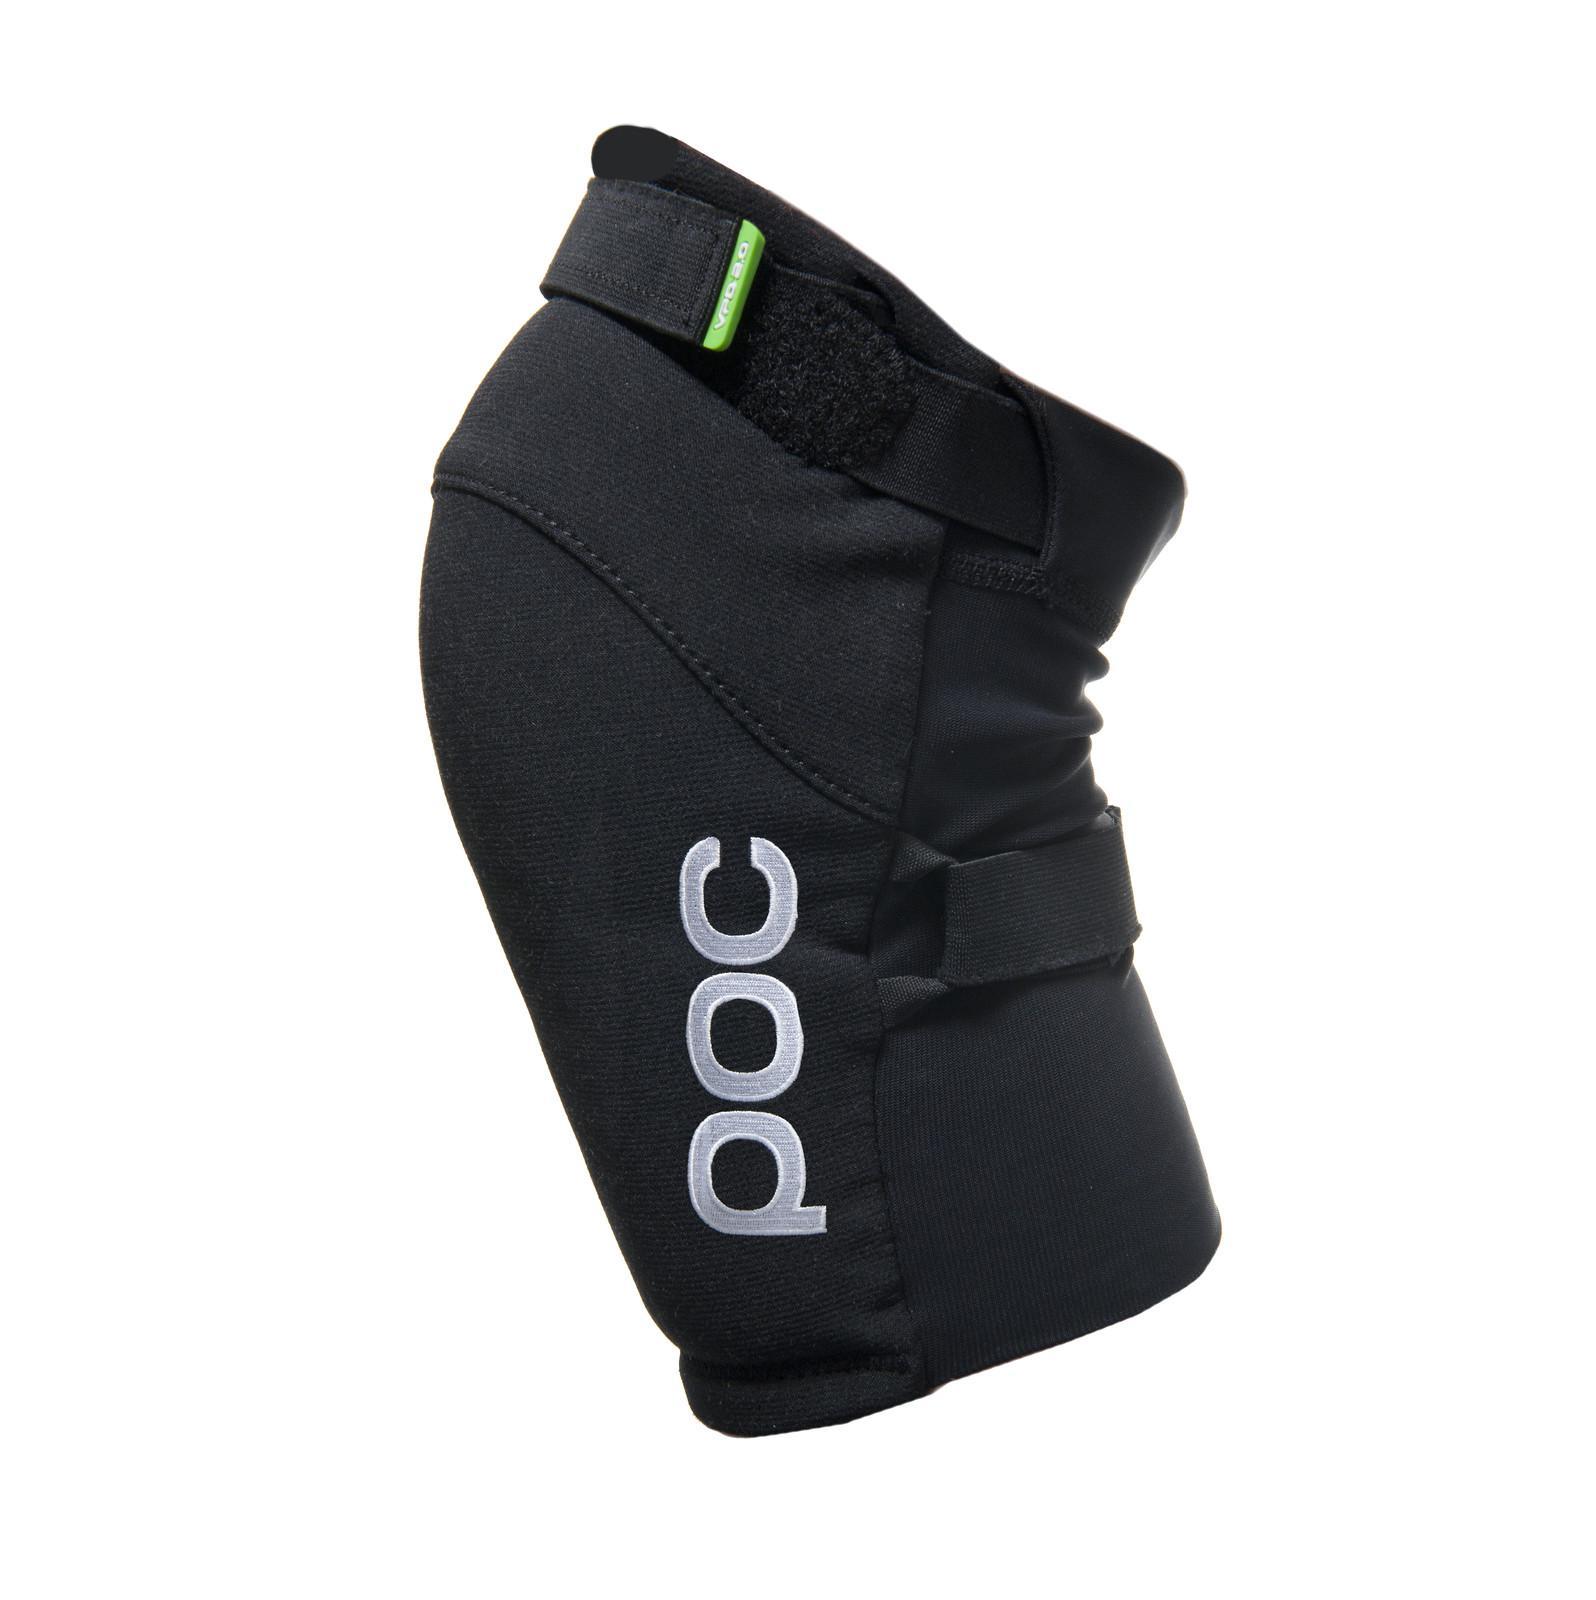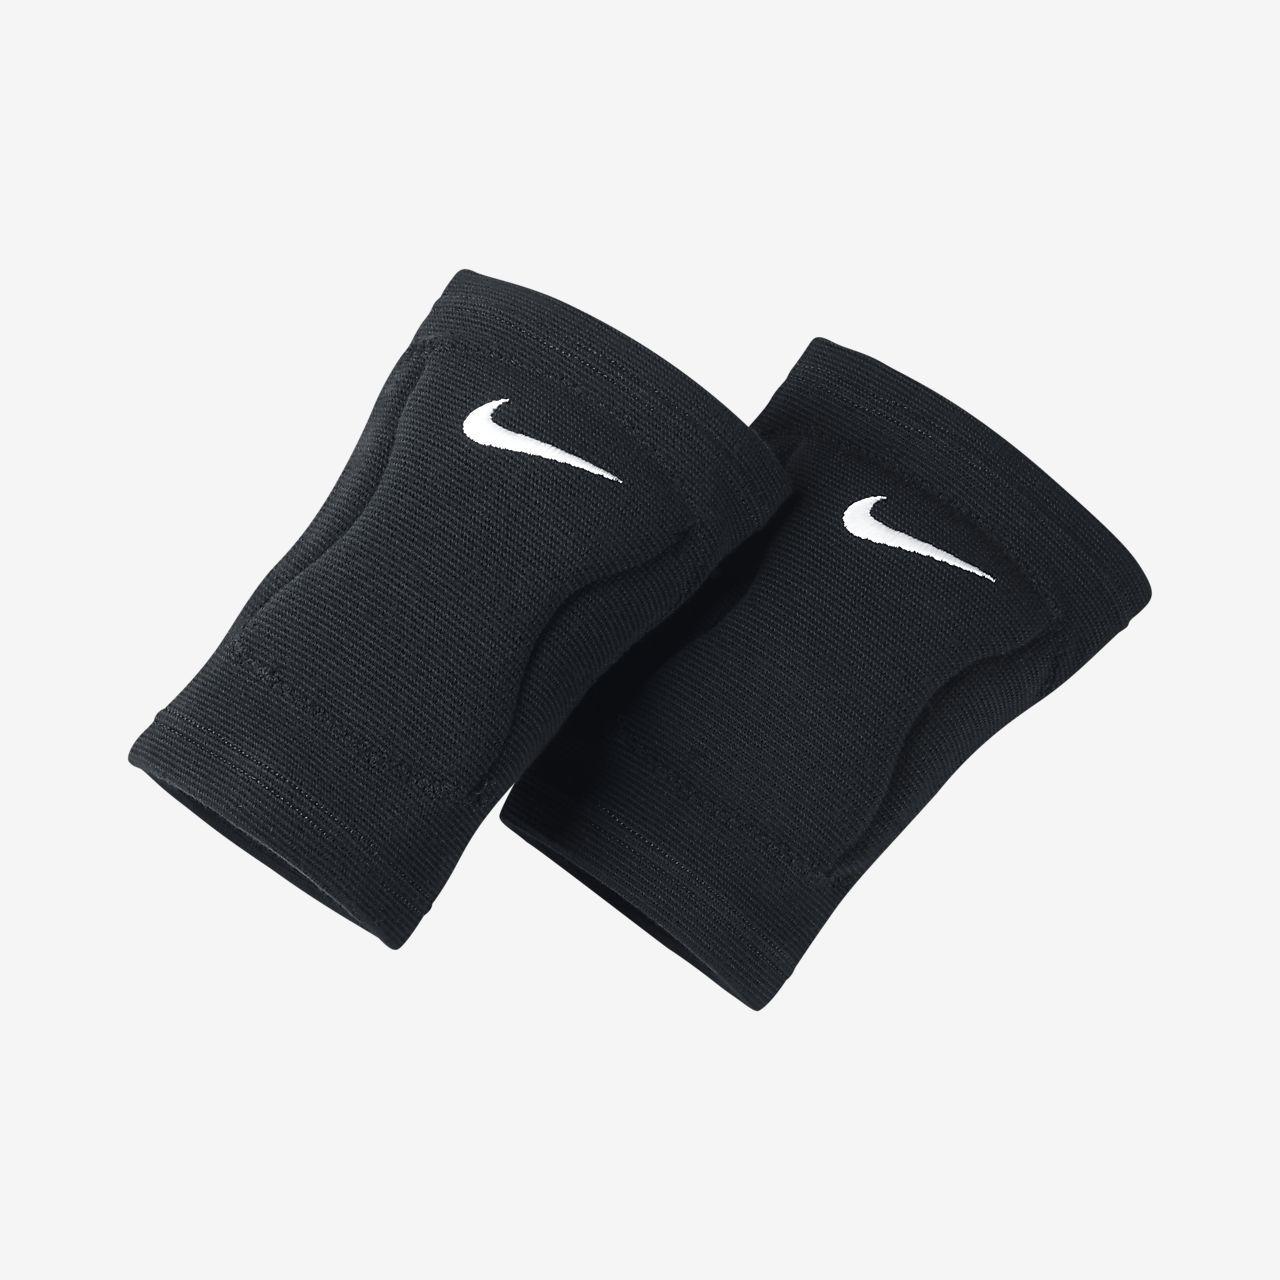The first image is the image on the left, the second image is the image on the right. Analyze the images presented: Is the assertion "Each image contains one pair of black knee pads, but only one image features a pair of knee pads with logos visible on each pad." valid? Answer yes or no. No. The first image is the image on the left, the second image is the image on the right. Given the left and right images, does the statement "There are two pairs of knee pads laying flat." hold true? Answer yes or no. No. 